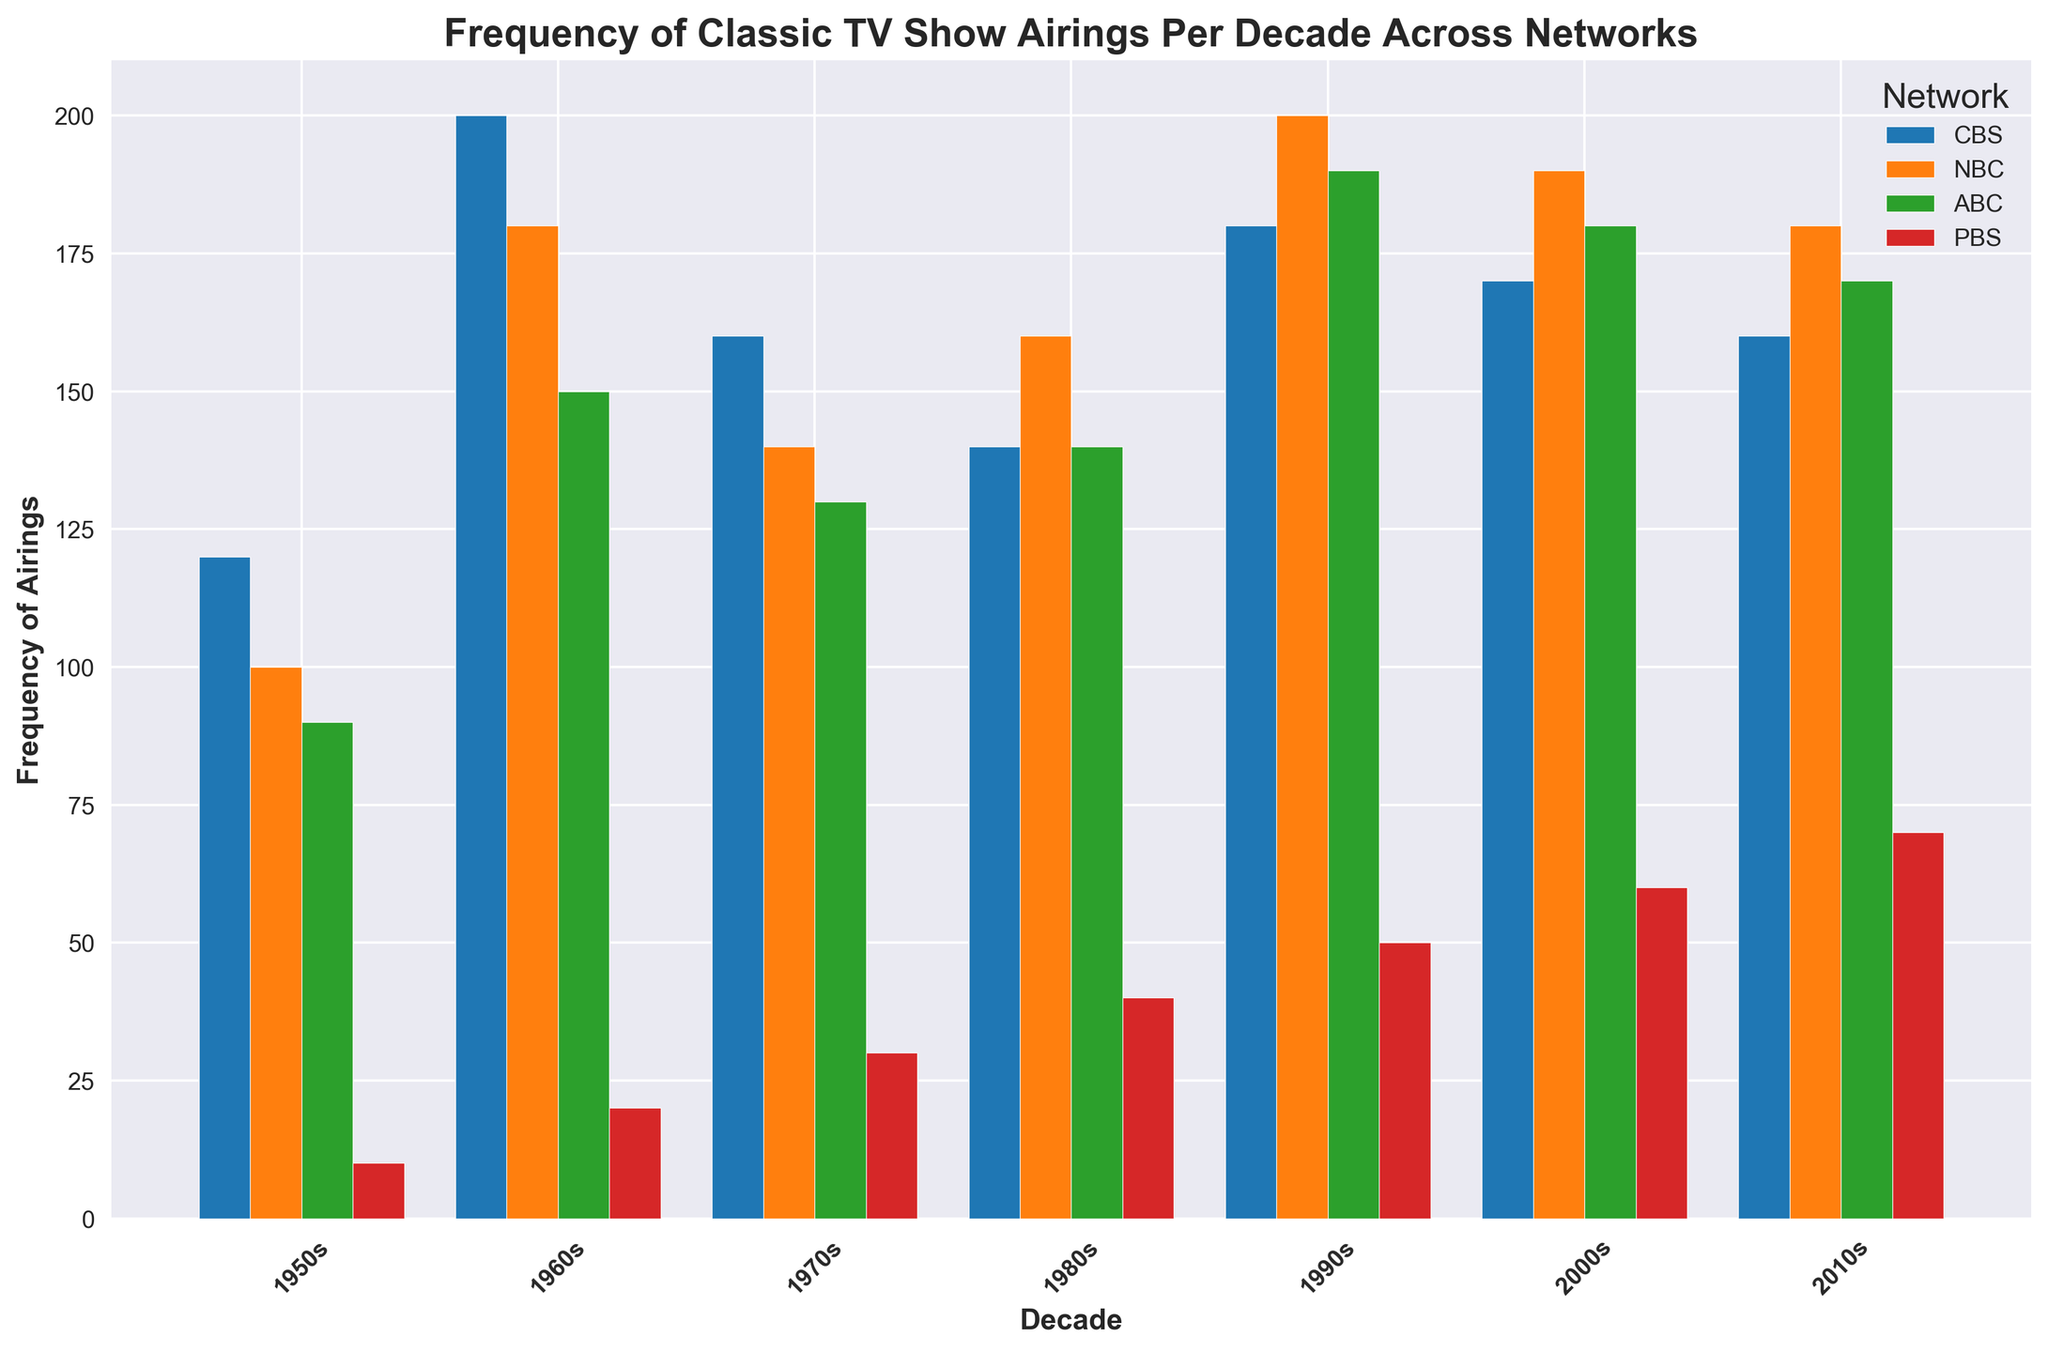What is the highest frequency of airings for CBS in any decade? To find this, look at the blue bars representing CBS across all decades. The highest column is in the 1960s with a frequency of 200.
Answer: 200 Which network had the lowest frequency of airings in the 1950s? Look at all the bars corresponding to the 1950s and identify the smallest one. The smallest is the red bar representing PBS with a frequency of 10.
Answer: PBS How does the frequency of airings for NBC in the 1980s compare to that in the 1990s? Look at the orange bars for NBC in the 1980s and 1990s. In the 1980s, NBC had 160 airings, and in the 1990s, NBC had 200 airings. The frequency increased by 40.
Answer: The frequency increased by 40 Compare the sum of airings for CBS and ABC in the 1970s. Which one had more, and by how much? Add the frequencies for CBS and ABC in the 1970s. CBS had 160, and ABC had 130. 160 - 130 = 30, so CBS had 30 more airings than ABC in the 1970s.
Answer: CBS had 30 more airings What is the trend in airings for PBS from the 1950s to the 2010s? Look at the red bars for PBS across the decades. The frequencies gradually increase from 10 in the 1950s to 70 in the 2010s, showing a clear upward trend.
Answer: Increasing Which decade had a higher total frequency of airings, the 1960s or the 2000s? Add up the frequencies for all networks in the 1960s (200+180+150+20=550) and the 2000s (170+190+180+60=600). The 2000s had a higher total frequency.
Answer: The 2000s Between ABC and NBC, which network had more airings in the 2010s, and by how many? Find the bars for ABC and NBC in the 2010s. ABC had 170 airings, and NBC had 180 airings. 180 - 170 = 10, so NBC had 10 more airings than ABC in the 2010s.
Answer: NBC by 10 